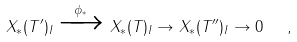<formula> <loc_0><loc_0><loc_500><loc_500>X _ { * } ( T ^ { \prime } ) _ { I } \xrightarrow { \phi _ { * } } X _ { * } ( T ) _ { I } \to X _ { * } ( T ^ { \prime \prime } ) _ { I } \to 0 \ \ ,</formula> 